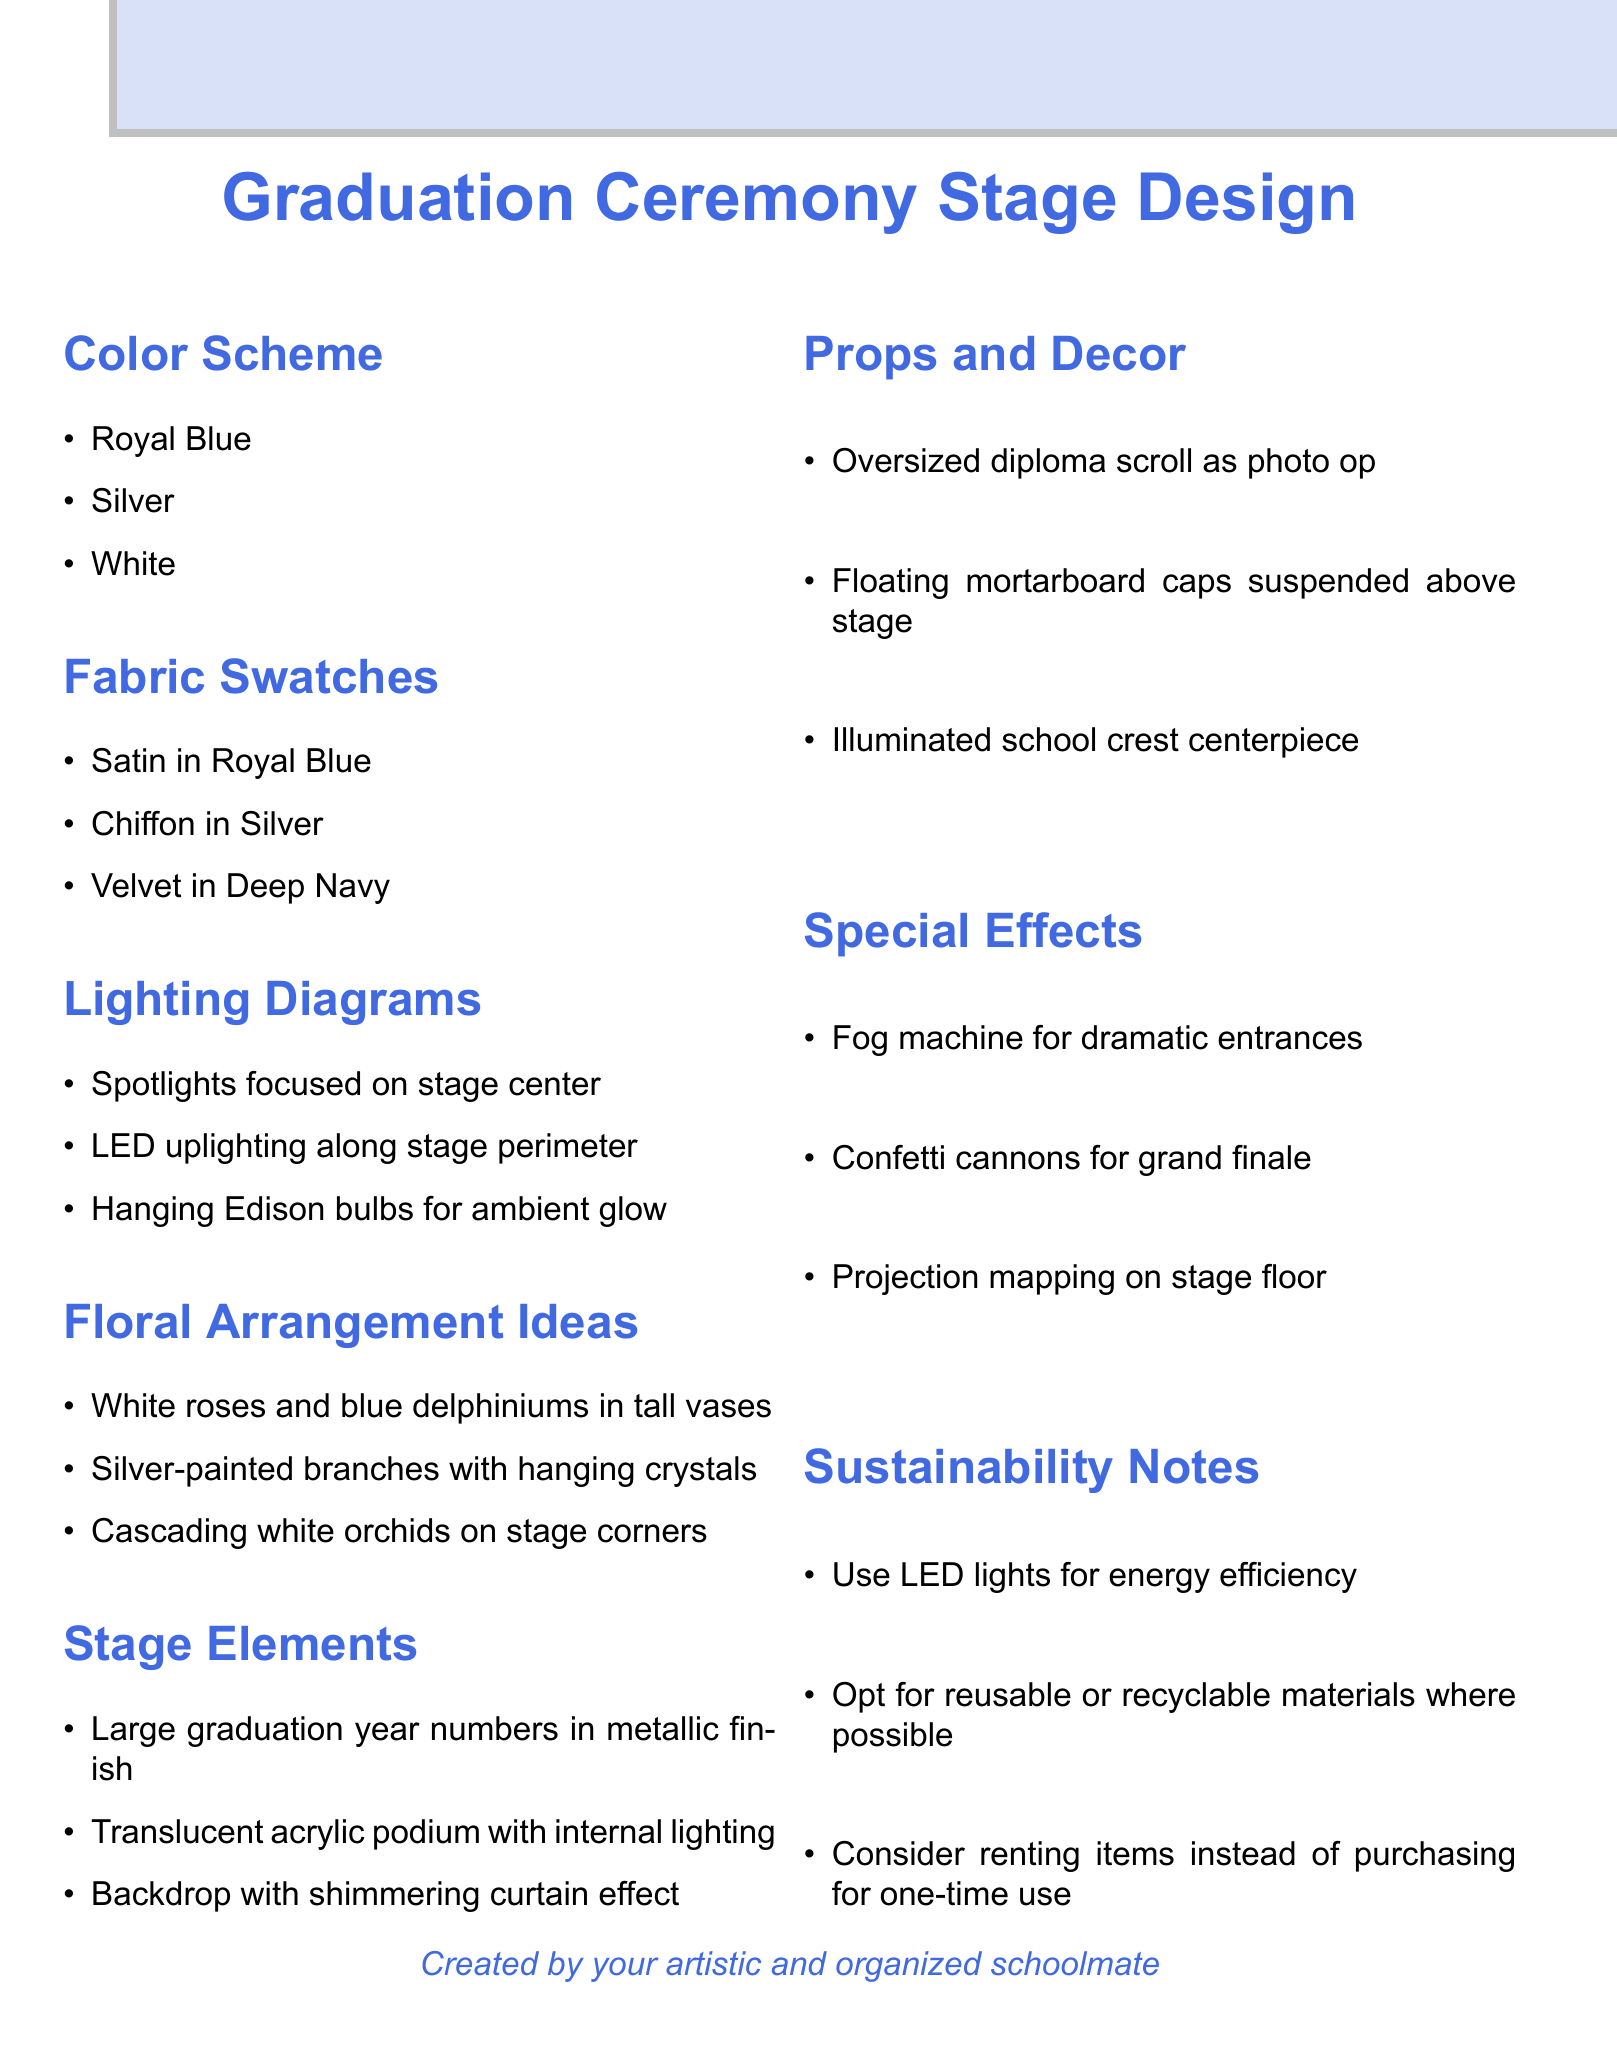What are the three main colors in the color scheme? The color scheme consists of three specified colors listed in the document.
Answer: Royal Blue, Silver, White How many fabric swatches are listed? The number of fabric swatches can be counted from the section in the document.
Answer: 3 What is the first floral arrangement idea mentioned? The first floral arrangement idea is the first item in its respective section in the document.
Answer: White roses and blue delphiniums in tall vases Which special effect is suggested for dramatic entrances? The special effect meant for dramatic entrances is identified in the special effects section.
Answer: Fog machine What kind of podium is included in the stage elements? The type of podium is described in the stage elements section of the document.
Answer: Translucent acrylic podium with internal lighting Name one sustainable practice mentioned in the document. A sustainable practice is specified in the sustainability notes section of the document.
Answer: Use LED lights for energy efficiency What is the theme for the props and decor? The props and decor section lists items that align with the overall theme of the event.
Answer: Oversized diploma scroll as photo op Which type of lighting is focused on the stage center? The lighting diagram mentions a specific type of lighting for the stage center.
Answer: Spotlights 